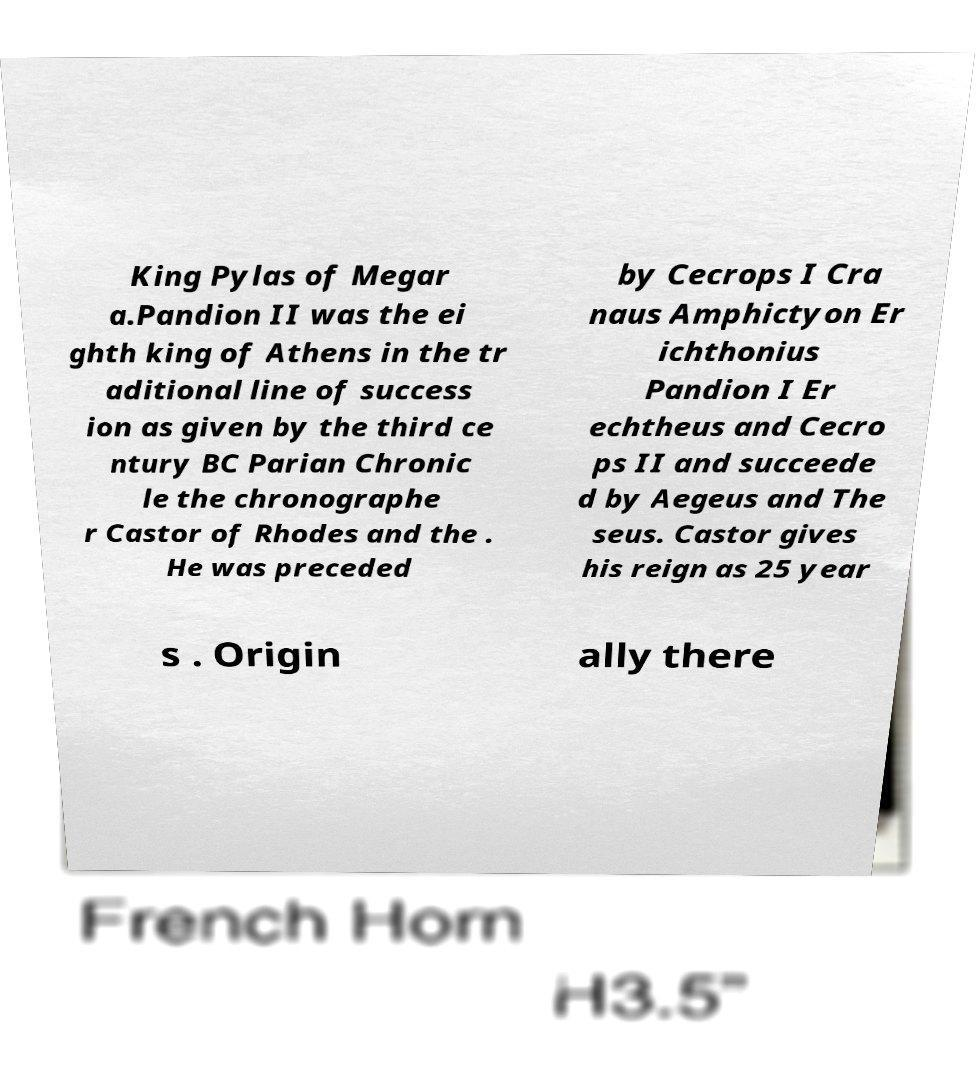For documentation purposes, I need the text within this image transcribed. Could you provide that? King Pylas of Megar a.Pandion II was the ei ghth king of Athens in the tr aditional line of success ion as given by the third ce ntury BC Parian Chronic le the chronographe r Castor of Rhodes and the . He was preceded by Cecrops I Cra naus Amphictyon Er ichthonius Pandion I Er echtheus and Cecro ps II and succeede d by Aegeus and The seus. Castor gives his reign as 25 year s . Origin ally there 